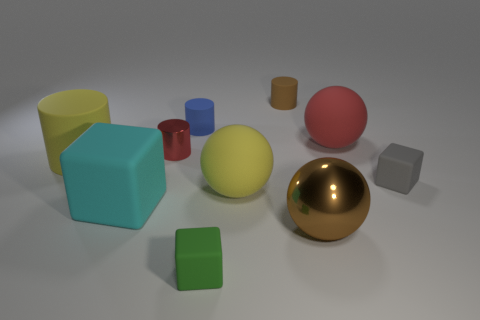Subtract 1 cylinders. How many cylinders are left? 3 Subtract all balls. How many objects are left? 7 Add 5 large blue balls. How many large blue balls exist? 5 Subtract 1 yellow cylinders. How many objects are left? 9 Subtract all small metal cylinders. Subtract all big brown metallic objects. How many objects are left? 8 Add 6 large yellow things. How many large yellow things are left? 8 